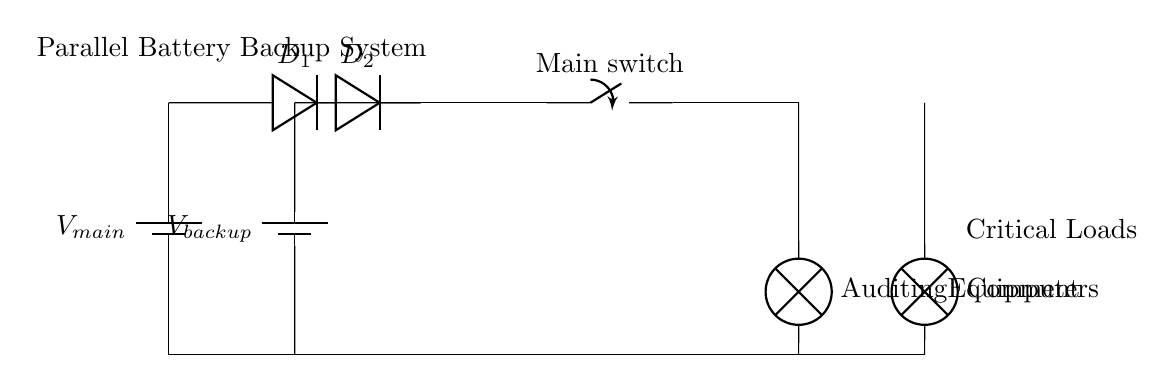What does the symbol $V_{main}$ represent? The symbol $V_{main}$ represents the main power supply voltage, which is the primary source of electrical energy for the circuit.
Answer: main power supply voltage How many diodes are used in this circuit? The circuit diagram shows two diodes, labeled as $D_1$ and $D_2$, used for isolation between the main and backup power supplies.
Answer: two What type of loads are connected in this circuit? The circuit includes critical loads, specifically an auditing equipment lamp and a computers lamp, indicating that these devices must remain powered during an outage.
Answer: auditing equipment and computers What is the purpose of the switch in this circuit? The switch, labeled as "Main switch," allows for the control of power distribution to the critical loads, enabling manual operation to disconnect or connect the loads as needed.
Answer: power control Which component allows for dual power sources to supply the loads? The two diodes ($D_1$ and $D_2$) facilitate the parallel connection of both power supplies, allowing them to supply the critical loads while preventing backflow of current.
Answer: diodes What happens to power supply when the main power fails? When the main power fails, the backup battery ($V_{backup}$) automatically supplies power to the critical loads, ensuring continuous operation.
Answer: backup battery provides power What is the significance of the ground connection in this circuit? The ground connection helps to stabilize the circuit by providing a common reference point for the voltages, ensuring safety and reliable operation of the equipment connected.
Answer: stabilize the circuit 